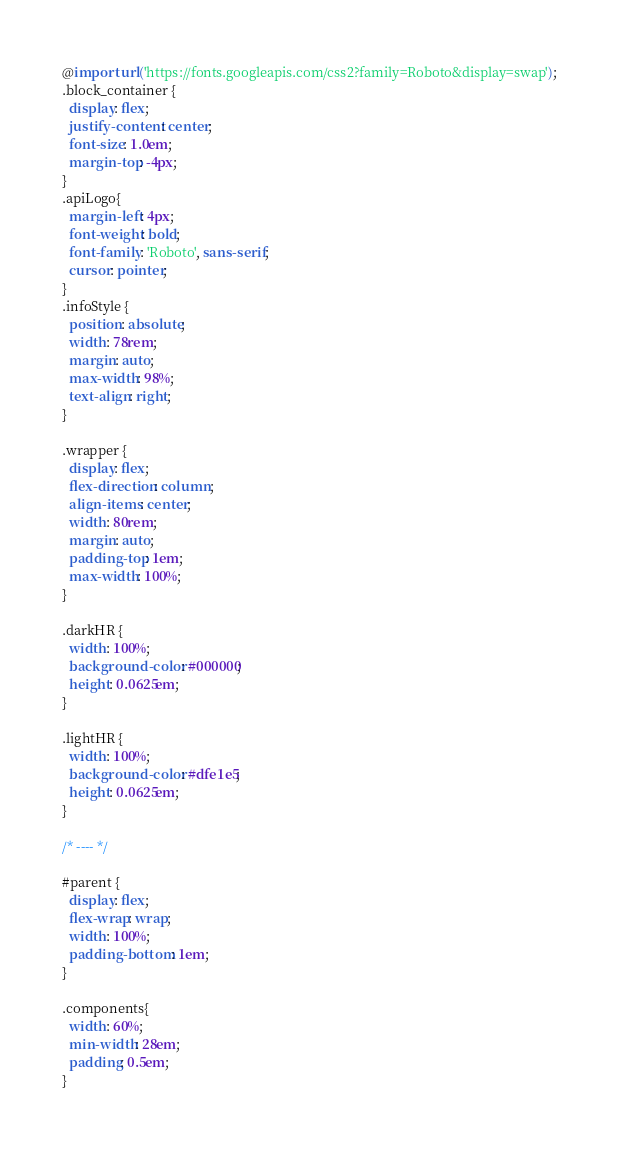Convert code to text. <code><loc_0><loc_0><loc_500><loc_500><_CSS_>@import url('https://fonts.googleapis.com/css2?family=Roboto&display=swap');
.block_container {
  display: flex;
  justify-content: center;
  font-size: 1.0em;
  margin-top: -4px;
}
.apiLogo{
  margin-left: 4px;
  font-weight: bold;
  font-family: 'Roboto', sans-serif;
  cursor: pointer;
}
.infoStyle {
  position: absolute;
  width: 78rem;
  margin: auto;
  max-width: 98%;
  text-align: right;
}

.wrapper {
  display: flex;
  flex-direction: column;
  align-items: center;
  width: 80rem;
  margin: auto;
  padding-top: 1em;
  max-width: 100%;
}

.darkHR {
  width: 100%;
  background-color: #000000;
  height: 0.0625em;
}

.lightHR {
  width: 100%;
  background-color: #dfe1e5;
  height: 0.0625em;
}

/* ---- */

#parent {
  display: flex;
  flex-wrap: wrap;
  width: 100%;
  padding-bottom: 1em;
}

.components{
  width: 60%;
  min-width: 28em;
  padding: 0.5em;
}


</code> 